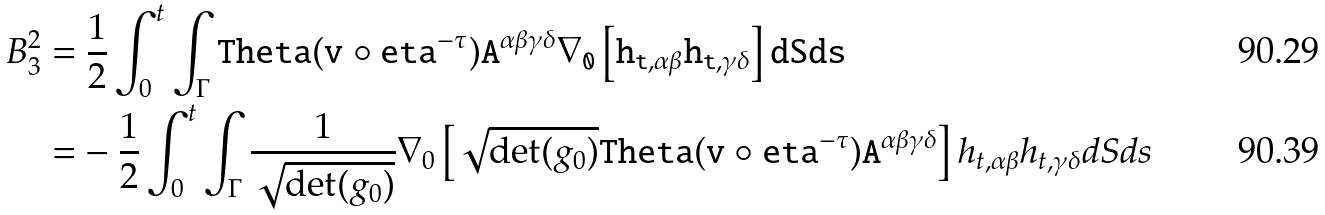Convert formula to latex. <formula><loc_0><loc_0><loc_500><loc_500>B _ { 3 } ^ { 2 } = & \ \frac { 1 } { 2 } \int _ { 0 } ^ { t } \int _ { \Gamma } \tt T h e t a ( \tt v \circ \tt e t a ^ { - \tau } ) \tt A ^ { \alpha \beta \gamma \delta } \nabla _ { 0 } \left [ h _ { t , \alpha \beta } h _ { t , \gamma \delta } \right ] d S d s \\ = & - \frac { 1 } { 2 } \int _ { 0 } ^ { t } \int _ { \Gamma } \frac { 1 } { \sqrt { \det ( g _ { 0 } ) } } \nabla _ { 0 } \left [ \sqrt { \det ( g _ { 0 } ) } \tt T h e t a ( \tt v \circ \tt e t a ^ { - \tau } ) \tt A ^ { \alpha \beta \gamma \delta } \right ] h _ { t , \alpha \beta } h _ { t , \gamma \delta } d S d s</formula> 